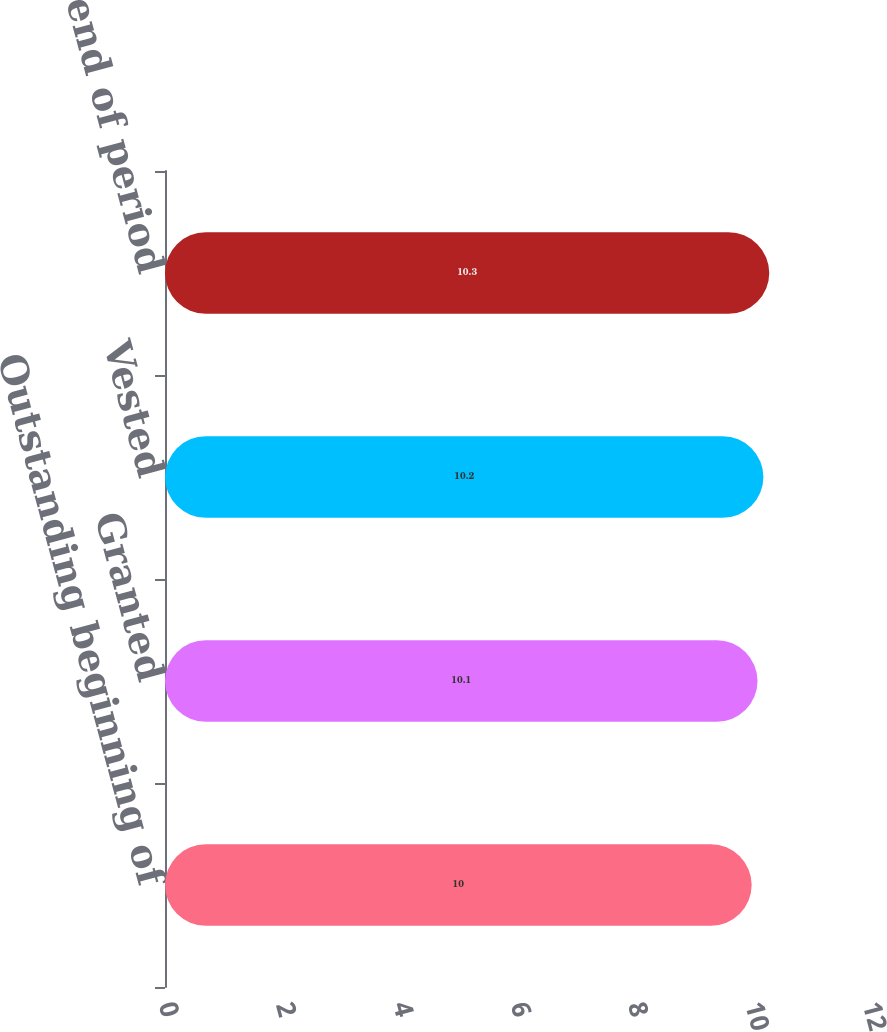Convert chart. <chart><loc_0><loc_0><loc_500><loc_500><bar_chart><fcel>Outstanding beginning of<fcel>Granted<fcel>Vested<fcel>Outstanding end of period<nl><fcel>10<fcel>10.1<fcel>10.2<fcel>10.3<nl></chart> 